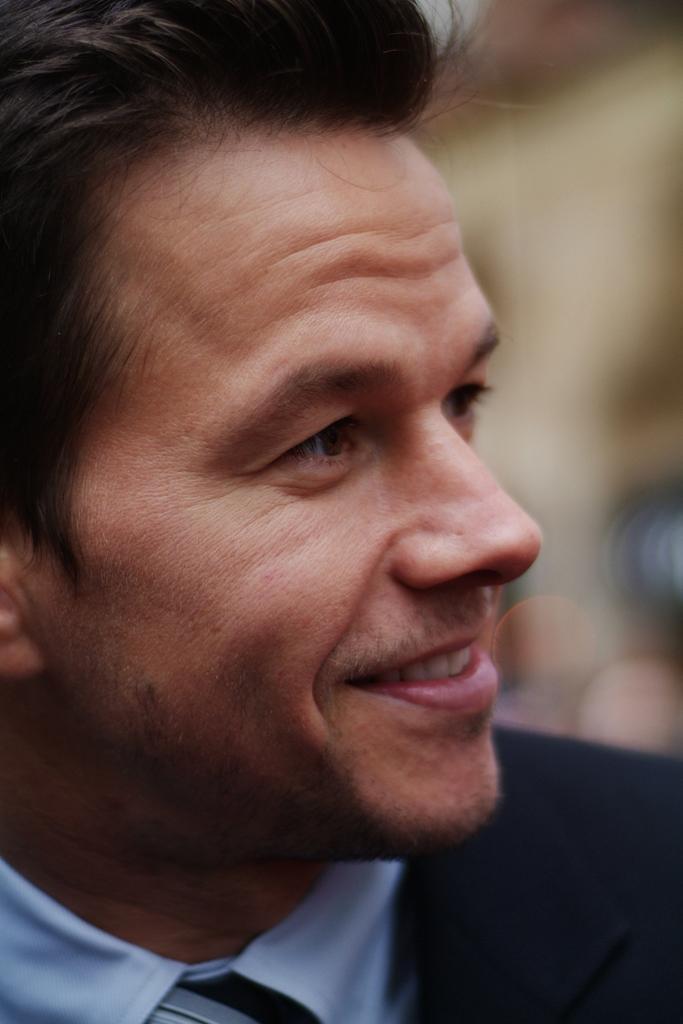In one or two sentences, can you explain what this image depicts? In this image we can see a man smiling. 